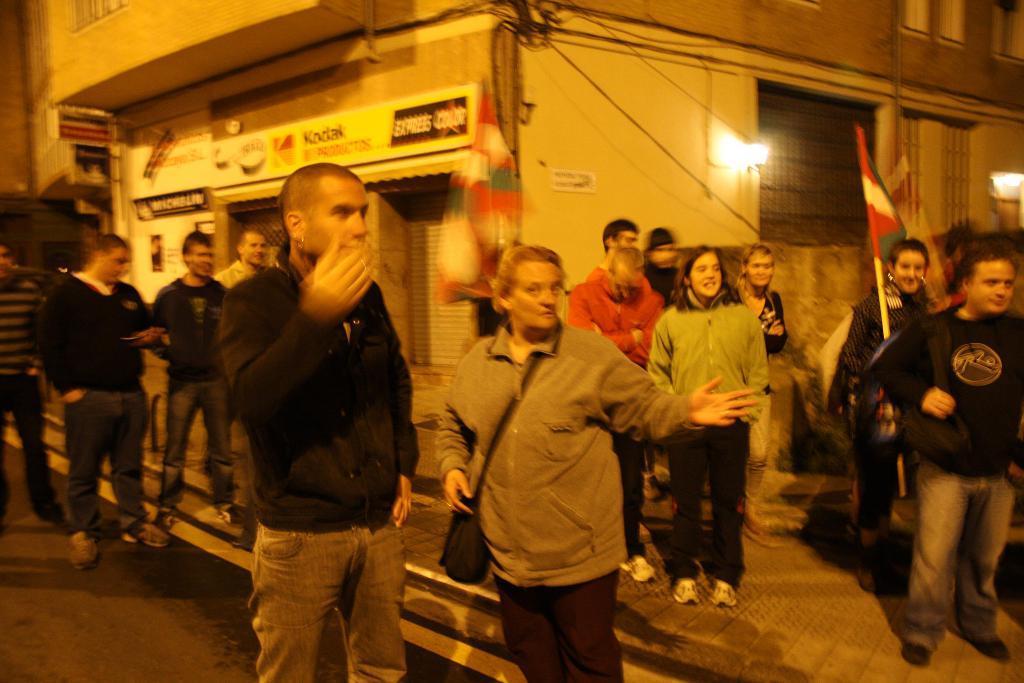In one or two sentences, can you explain what this image depicts? In this image there is a group of people standing on the roads and pavement are holding flags in their hands, behind them there is a closed shutter of a shop of a building, there are grill windows and lamps on the building. 